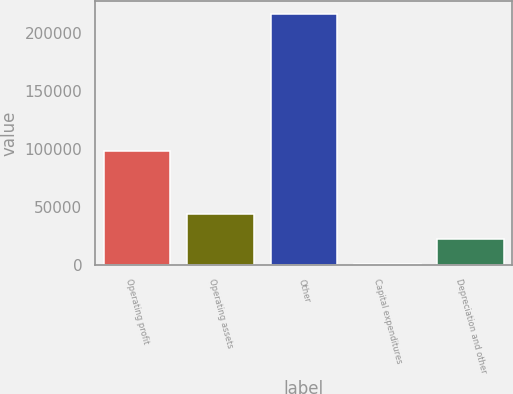<chart> <loc_0><loc_0><loc_500><loc_500><bar_chart><fcel>Operating profit<fcel>Operating assets<fcel>Other<fcel>Capital expenditures<fcel>Depreciation and other<nl><fcel>98188<fcel>43596.4<fcel>216598<fcel>346<fcel>21971.2<nl></chart> 